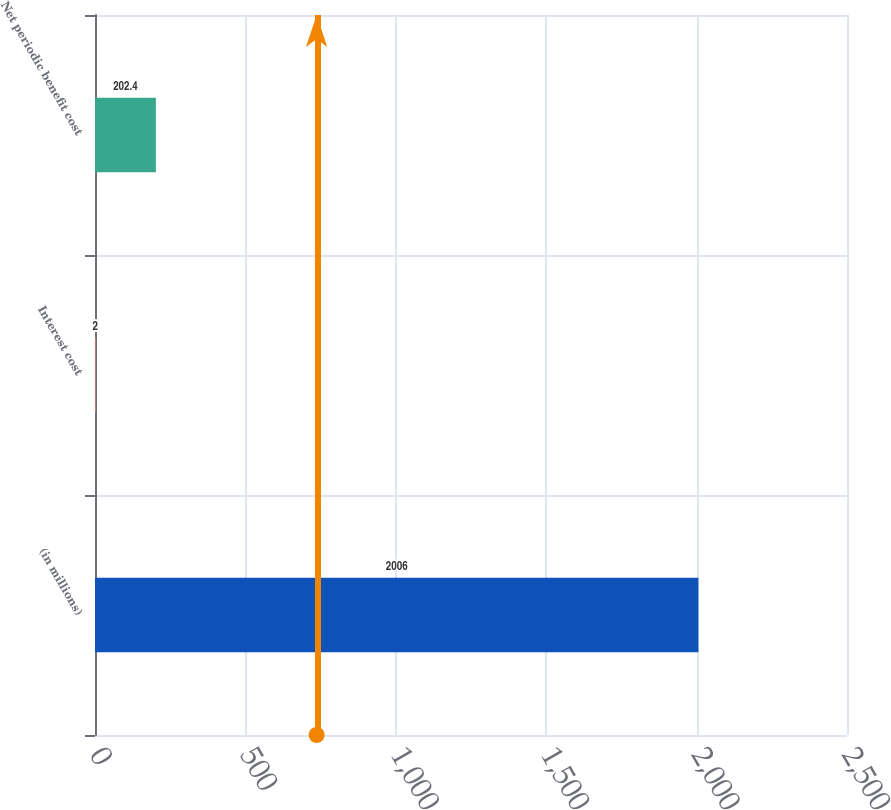Convert chart. <chart><loc_0><loc_0><loc_500><loc_500><bar_chart><fcel>(in millions)<fcel>Interest cost<fcel>Net periodic benefit cost<nl><fcel>2006<fcel>2<fcel>202.4<nl></chart> 